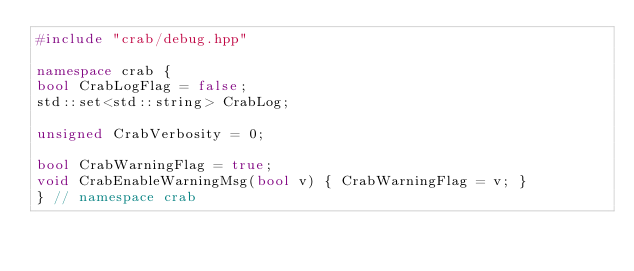<code> <loc_0><loc_0><loc_500><loc_500><_C++_>#include "crab/debug.hpp"

namespace crab {
bool CrabLogFlag = false;
std::set<std::string> CrabLog;

unsigned CrabVerbosity = 0;

bool CrabWarningFlag = true;
void CrabEnableWarningMsg(bool v) { CrabWarningFlag = v; }
} // namespace crab
</code> 